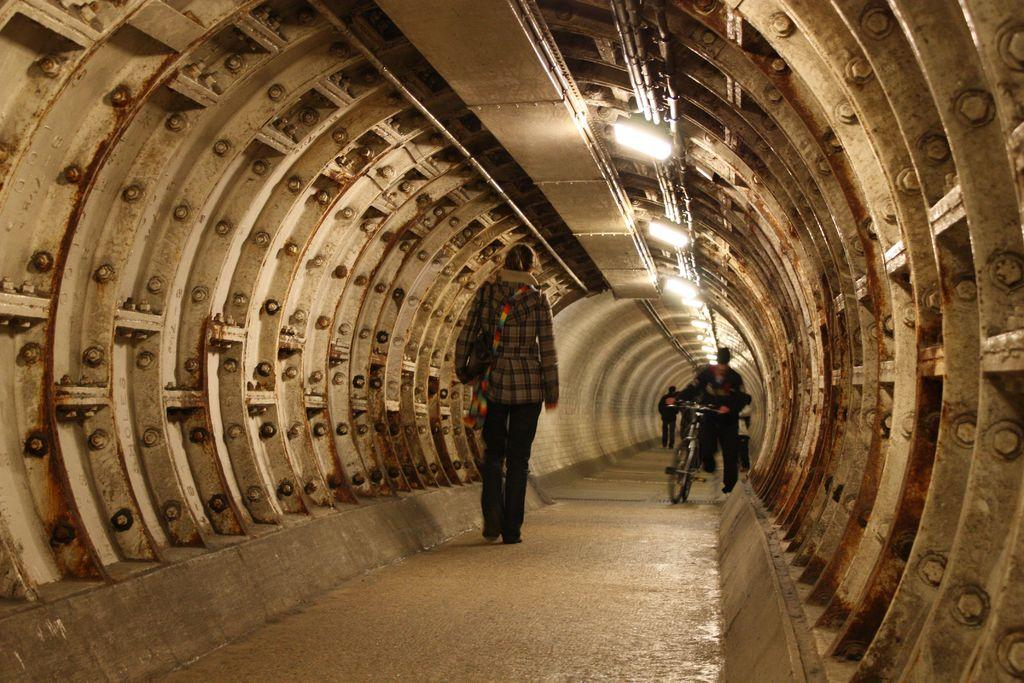Where is the image taken? The image is taken inside a tunnel. What can be seen happening in the image? There are people walking in the image. What type of police vehicle can be seen parked near the moon in the image? There is no police vehicle or moon present in the image; it is taken inside a tunnel with people walking. 